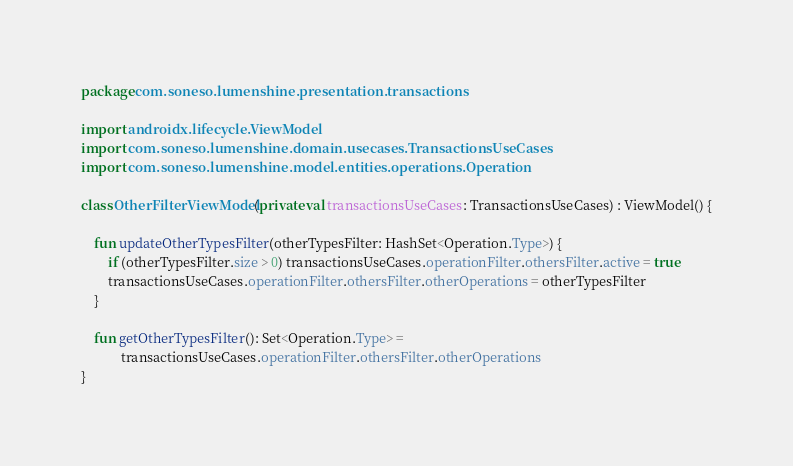Convert code to text. <code><loc_0><loc_0><loc_500><loc_500><_Kotlin_>package com.soneso.lumenshine.presentation.transactions

import androidx.lifecycle.ViewModel
import com.soneso.lumenshine.domain.usecases.TransactionsUseCases
import com.soneso.lumenshine.model.entities.operations.Operation

class OtherFilterViewModel(private val transactionsUseCases: TransactionsUseCases) : ViewModel() {

    fun updateOtherTypesFilter(otherTypesFilter: HashSet<Operation.Type>) {
        if (otherTypesFilter.size > 0) transactionsUseCases.operationFilter.othersFilter.active = true
        transactionsUseCases.operationFilter.othersFilter.otherOperations = otherTypesFilter
    }

    fun getOtherTypesFilter(): Set<Operation.Type> =
            transactionsUseCases.operationFilter.othersFilter.otherOperations
}</code> 